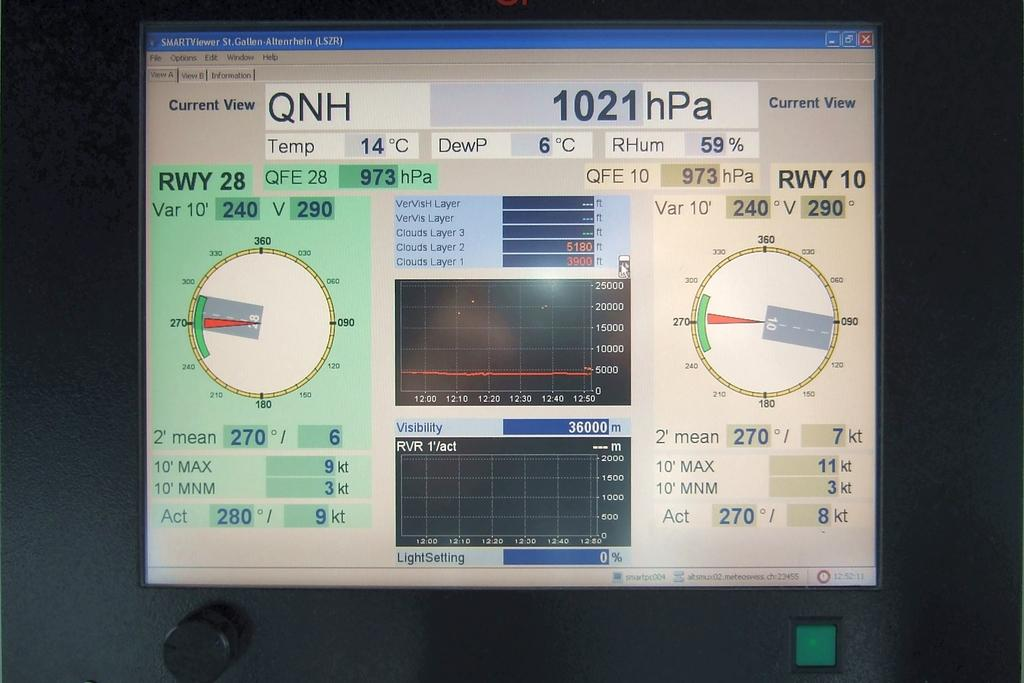<image>
Describe the image concisely. a monitor with a 1021 hPa message on it 